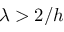<formula> <loc_0><loc_0><loc_500><loc_500>\lambda > 2 / h</formula> 